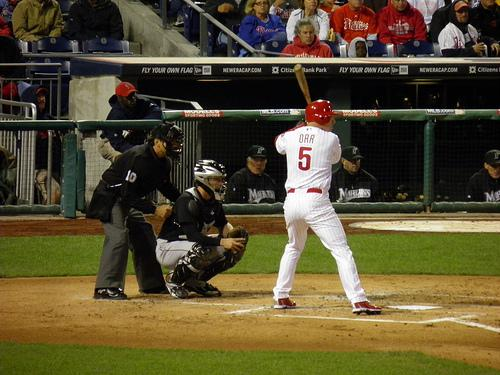Question: when will he hit the ball?
Choices:
A. Today.
B. After the pitcher throws it.
C. Soon.
D. During the game.
Answer with the letter. Answer: C Question: why is the guy kneeling?
Choices:
A. He is injured.
B. He is praying.
C. Catcher.
D. He is looking for the ball.
Answer with the letter. Answer: C Question: what is he waiting for?
Choices:
A. The umpire's decision.
B. The pitch.
C. The beginning of the game.
D. The arrival of his teammates.
Answer with the letter. Answer: B 